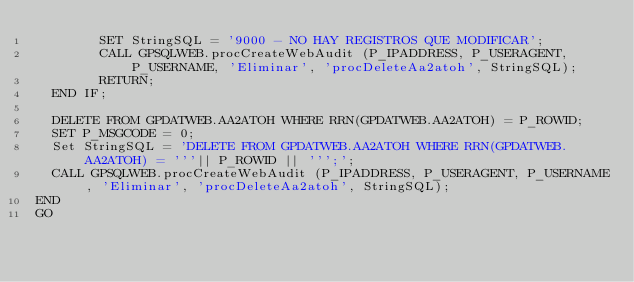<code> <loc_0><loc_0><loc_500><loc_500><_SQL_>        SET StringSQL = '9000 - NO HAY REGISTROS QUE MODIFICAR';
        CALL GPSQLWEB.procCreateWebAudit (P_IPADDRESS, P_USERAGENT, P_USERNAME, 'Eliminar', 'procDeleteAa2atoh', StringSQL);
        RETURN;
  END IF;
  
  DELETE FROM GPDATWEB.AA2ATOH WHERE RRN(GPDATWEB.AA2ATOH) = P_ROWID;
  SET P_MSGCODE = 0;
  Set StringSQL = 'DELETE FROM GPDATWEB.AA2ATOH WHERE RRN(GPDATWEB.AA2ATOH) = '''|| P_ROWID || ''';';
  CALL GPSQLWEB.procCreateWebAudit (P_IPADDRESS, P_USERAGENT, P_USERNAME, 'Eliminar', 'procDeleteAa2atoh', StringSQL);
END
GO
</code> 